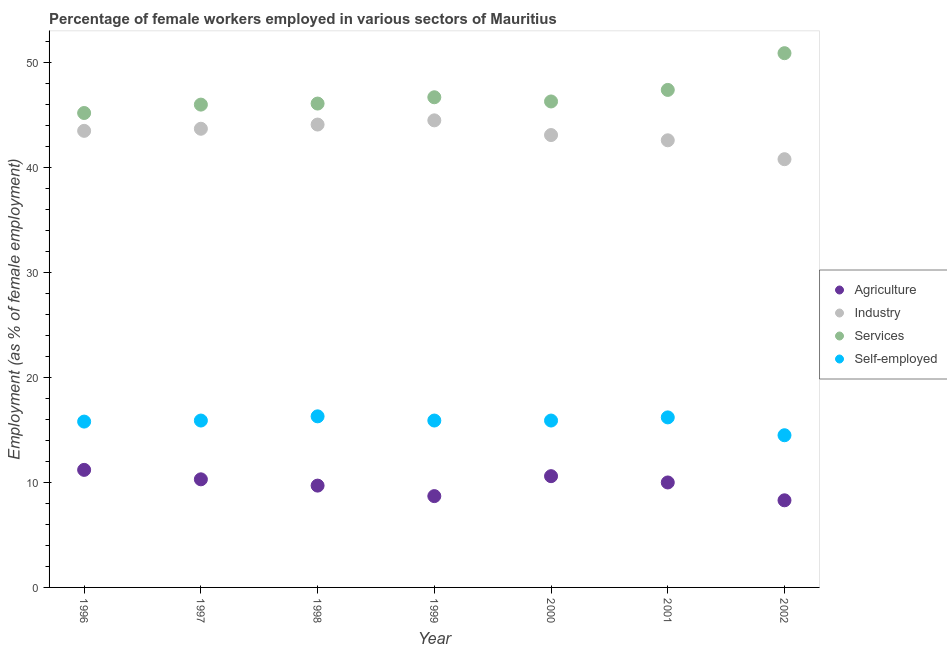How many different coloured dotlines are there?
Ensure brevity in your answer.  4. What is the percentage of female workers in industry in 1996?
Offer a terse response. 43.5. Across all years, what is the maximum percentage of female workers in industry?
Ensure brevity in your answer.  44.5. In which year was the percentage of female workers in agriculture maximum?
Offer a very short reply. 1996. In which year was the percentage of female workers in industry minimum?
Your answer should be compact. 2002. What is the total percentage of self employed female workers in the graph?
Your answer should be very brief. 110.5. What is the difference between the percentage of female workers in industry in 1996 and that in 1997?
Ensure brevity in your answer.  -0.2. What is the difference between the percentage of self employed female workers in 1999 and the percentage of female workers in industry in 2000?
Your answer should be compact. -27.2. What is the average percentage of female workers in industry per year?
Ensure brevity in your answer.  43.19. In the year 1996, what is the difference between the percentage of female workers in services and percentage of female workers in industry?
Offer a very short reply. 1.7. In how many years, is the percentage of female workers in agriculture greater than 22 %?
Make the answer very short. 0. What is the ratio of the percentage of female workers in services in 1999 to that in 2000?
Ensure brevity in your answer.  1.01. Is the percentage of female workers in agriculture in 1997 less than that in 2002?
Give a very brief answer. No. Is the difference between the percentage of female workers in industry in 2000 and 2002 greater than the difference between the percentage of self employed female workers in 2000 and 2002?
Keep it short and to the point. Yes. What is the difference between the highest and the second highest percentage of female workers in agriculture?
Your answer should be very brief. 0.6. What is the difference between the highest and the lowest percentage of self employed female workers?
Your response must be concise. 1.8. In how many years, is the percentage of female workers in agriculture greater than the average percentage of female workers in agriculture taken over all years?
Offer a very short reply. 4. Is the sum of the percentage of female workers in industry in 1996 and 2001 greater than the maximum percentage of female workers in agriculture across all years?
Your answer should be very brief. Yes. Is it the case that in every year, the sum of the percentage of female workers in industry and percentage of female workers in services is greater than the sum of percentage of female workers in agriculture and percentage of self employed female workers?
Offer a terse response. Yes. Is it the case that in every year, the sum of the percentage of female workers in agriculture and percentage of female workers in industry is greater than the percentage of female workers in services?
Keep it short and to the point. No. Does the percentage of female workers in industry monotonically increase over the years?
Offer a very short reply. No. Is the percentage of female workers in services strictly less than the percentage of female workers in industry over the years?
Give a very brief answer. No. How many years are there in the graph?
Keep it short and to the point. 7. What is the difference between two consecutive major ticks on the Y-axis?
Your answer should be compact. 10. Are the values on the major ticks of Y-axis written in scientific E-notation?
Your response must be concise. No. Does the graph contain any zero values?
Make the answer very short. No. Does the graph contain grids?
Offer a terse response. No. How are the legend labels stacked?
Make the answer very short. Vertical. What is the title of the graph?
Ensure brevity in your answer.  Percentage of female workers employed in various sectors of Mauritius. What is the label or title of the Y-axis?
Your answer should be very brief. Employment (as % of female employment). What is the Employment (as % of female employment) in Agriculture in 1996?
Offer a terse response. 11.2. What is the Employment (as % of female employment) of Industry in 1996?
Give a very brief answer. 43.5. What is the Employment (as % of female employment) in Services in 1996?
Make the answer very short. 45.2. What is the Employment (as % of female employment) in Self-employed in 1996?
Offer a very short reply. 15.8. What is the Employment (as % of female employment) of Agriculture in 1997?
Your response must be concise. 10.3. What is the Employment (as % of female employment) in Industry in 1997?
Keep it short and to the point. 43.7. What is the Employment (as % of female employment) of Self-employed in 1997?
Keep it short and to the point. 15.9. What is the Employment (as % of female employment) of Agriculture in 1998?
Offer a terse response. 9.7. What is the Employment (as % of female employment) in Industry in 1998?
Give a very brief answer. 44.1. What is the Employment (as % of female employment) of Services in 1998?
Provide a succinct answer. 46.1. What is the Employment (as % of female employment) in Self-employed in 1998?
Your answer should be compact. 16.3. What is the Employment (as % of female employment) in Agriculture in 1999?
Make the answer very short. 8.7. What is the Employment (as % of female employment) of Industry in 1999?
Offer a terse response. 44.5. What is the Employment (as % of female employment) in Services in 1999?
Keep it short and to the point. 46.7. What is the Employment (as % of female employment) in Self-employed in 1999?
Provide a succinct answer. 15.9. What is the Employment (as % of female employment) in Agriculture in 2000?
Give a very brief answer. 10.6. What is the Employment (as % of female employment) of Industry in 2000?
Provide a short and direct response. 43.1. What is the Employment (as % of female employment) of Services in 2000?
Your answer should be very brief. 46.3. What is the Employment (as % of female employment) of Self-employed in 2000?
Give a very brief answer. 15.9. What is the Employment (as % of female employment) of Agriculture in 2001?
Give a very brief answer. 10. What is the Employment (as % of female employment) of Industry in 2001?
Offer a very short reply. 42.6. What is the Employment (as % of female employment) in Services in 2001?
Provide a succinct answer. 47.4. What is the Employment (as % of female employment) in Self-employed in 2001?
Make the answer very short. 16.2. What is the Employment (as % of female employment) in Agriculture in 2002?
Offer a very short reply. 8.3. What is the Employment (as % of female employment) in Industry in 2002?
Your response must be concise. 40.8. What is the Employment (as % of female employment) of Services in 2002?
Provide a succinct answer. 50.9. Across all years, what is the maximum Employment (as % of female employment) in Agriculture?
Offer a very short reply. 11.2. Across all years, what is the maximum Employment (as % of female employment) in Industry?
Your response must be concise. 44.5. Across all years, what is the maximum Employment (as % of female employment) of Services?
Keep it short and to the point. 50.9. Across all years, what is the maximum Employment (as % of female employment) of Self-employed?
Offer a terse response. 16.3. Across all years, what is the minimum Employment (as % of female employment) of Agriculture?
Keep it short and to the point. 8.3. Across all years, what is the minimum Employment (as % of female employment) of Industry?
Make the answer very short. 40.8. Across all years, what is the minimum Employment (as % of female employment) in Services?
Keep it short and to the point. 45.2. Across all years, what is the minimum Employment (as % of female employment) in Self-employed?
Provide a succinct answer. 14.5. What is the total Employment (as % of female employment) in Agriculture in the graph?
Your response must be concise. 68.8. What is the total Employment (as % of female employment) of Industry in the graph?
Your answer should be very brief. 302.3. What is the total Employment (as % of female employment) in Services in the graph?
Ensure brevity in your answer.  328.6. What is the total Employment (as % of female employment) in Self-employed in the graph?
Provide a short and direct response. 110.5. What is the difference between the Employment (as % of female employment) of Agriculture in 1996 and that in 1997?
Your answer should be compact. 0.9. What is the difference between the Employment (as % of female employment) of Industry in 1996 and that in 1997?
Give a very brief answer. -0.2. What is the difference between the Employment (as % of female employment) of Self-employed in 1996 and that in 1997?
Ensure brevity in your answer.  -0.1. What is the difference between the Employment (as % of female employment) of Self-employed in 1996 and that in 1998?
Ensure brevity in your answer.  -0.5. What is the difference between the Employment (as % of female employment) of Agriculture in 1996 and that in 1999?
Your answer should be compact. 2.5. What is the difference between the Employment (as % of female employment) of Industry in 1996 and that in 1999?
Provide a succinct answer. -1. What is the difference between the Employment (as % of female employment) in Services in 1996 and that in 1999?
Your answer should be very brief. -1.5. What is the difference between the Employment (as % of female employment) in Self-employed in 1996 and that in 1999?
Make the answer very short. -0.1. What is the difference between the Employment (as % of female employment) in Agriculture in 1996 and that in 2000?
Offer a very short reply. 0.6. What is the difference between the Employment (as % of female employment) of Industry in 1996 and that in 2000?
Your answer should be very brief. 0.4. What is the difference between the Employment (as % of female employment) in Services in 1996 and that in 2000?
Your answer should be very brief. -1.1. What is the difference between the Employment (as % of female employment) in Self-employed in 1996 and that in 2000?
Offer a terse response. -0.1. What is the difference between the Employment (as % of female employment) in Industry in 1996 and that in 2001?
Ensure brevity in your answer.  0.9. What is the difference between the Employment (as % of female employment) in Self-employed in 1996 and that in 2001?
Your answer should be compact. -0.4. What is the difference between the Employment (as % of female employment) of Agriculture in 1996 and that in 2002?
Provide a succinct answer. 2.9. What is the difference between the Employment (as % of female employment) in Services in 1996 and that in 2002?
Your answer should be very brief. -5.7. What is the difference between the Employment (as % of female employment) of Self-employed in 1996 and that in 2002?
Offer a very short reply. 1.3. What is the difference between the Employment (as % of female employment) of Agriculture in 1997 and that in 1998?
Offer a very short reply. 0.6. What is the difference between the Employment (as % of female employment) in Self-employed in 1997 and that in 1998?
Your response must be concise. -0.4. What is the difference between the Employment (as % of female employment) of Agriculture in 1997 and that in 1999?
Ensure brevity in your answer.  1.6. What is the difference between the Employment (as % of female employment) in Industry in 1997 and that in 1999?
Offer a terse response. -0.8. What is the difference between the Employment (as % of female employment) in Services in 1997 and that in 1999?
Your response must be concise. -0.7. What is the difference between the Employment (as % of female employment) in Self-employed in 1997 and that in 1999?
Make the answer very short. 0. What is the difference between the Employment (as % of female employment) in Agriculture in 1997 and that in 2000?
Your response must be concise. -0.3. What is the difference between the Employment (as % of female employment) in Industry in 1997 and that in 2000?
Provide a short and direct response. 0.6. What is the difference between the Employment (as % of female employment) in Industry in 1997 and that in 2001?
Your answer should be compact. 1.1. What is the difference between the Employment (as % of female employment) of Industry in 1997 and that in 2002?
Offer a very short reply. 2.9. What is the difference between the Employment (as % of female employment) in Services in 1997 and that in 2002?
Ensure brevity in your answer.  -4.9. What is the difference between the Employment (as % of female employment) in Agriculture in 1998 and that in 1999?
Offer a terse response. 1. What is the difference between the Employment (as % of female employment) of Agriculture in 1998 and that in 2000?
Keep it short and to the point. -0.9. What is the difference between the Employment (as % of female employment) of Industry in 1998 and that in 2000?
Your response must be concise. 1. What is the difference between the Employment (as % of female employment) in Self-employed in 1998 and that in 2000?
Keep it short and to the point. 0.4. What is the difference between the Employment (as % of female employment) of Agriculture in 1998 and that in 2001?
Ensure brevity in your answer.  -0.3. What is the difference between the Employment (as % of female employment) in Industry in 1998 and that in 2001?
Keep it short and to the point. 1.5. What is the difference between the Employment (as % of female employment) in Agriculture in 1998 and that in 2002?
Keep it short and to the point. 1.4. What is the difference between the Employment (as % of female employment) in Industry in 1998 and that in 2002?
Your answer should be very brief. 3.3. What is the difference between the Employment (as % of female employment) of Services in 1998 and that in 2002?
Keep it short and to the point. -4.8. What is the difference between the Employment (as % of female employment) of Self-employed in 1998 and that in 2002?
Offer a terse response. 1.8. What is the difference between the Employment (as % of female employment) in Agriculture in 1999 and that in 2000?
Make the answer very short. -1.9. What is the difference between the Employment (as % of female employment) of Industry in 1999 and that in 2000?
Your answer should be compact. 1.4. What is the difference between the Employment (as % of female employment) in Self-employed in 1999 and that in 2000?
Make the answer very short. 0. What is the difference between the Employment (as % of female employment) of Industry in 1999 and that in 2001?
Make the answer very short. 1.9. What is the difference between the Employment (as % of female employment) in Agriculture in 1999 and that in 2002?
Ensure brevity in your answer.  0.4. What is the difference between the Employment (as % of female employment) of Industry in 1999 and that in 2002?
Provide a short and direct response. 3.7. What is the difference between the Employment (as % of female employment) in Self-employed in 1999 and that in 2002?
Make the answer very short. 1.4. What is the difference between the Employment (as % of female employment) of Agriculture in 2000 and that in 2001?
Your answer should be compact. 0.6. What is the difference between the Employment (as % of female employment) in Services in 2000 and that in 2001?
Ensure brevity in your answer.  -1.1. What is the difference between the Employment (as % of female employment) in Self-employed in 2000 and that in 2001?
Keep it short and to the point. -0.3. What is the difference between the Employment (as % of female employment) of Agriculture in 2000 and that in 2002?
Your response must be concise. 2.3. What is the difference between the Employment (as % of female employment) of Industry in 2000 and that in 2002?
Keep it short and to the point. 2.3. What is the difference between the Employment (as % of female employment) of Self-employed in 2000 and that in 2002?
Keep it short and to the point. 1.4. What is the difference between the Employment (as % of female employment) of Agriculture in 2001 and that in 2002?
Ensure brevity in your answer.  1.7. What is the difference between the Employment (as % of female employment) in Services in 2001 and that in 2002?
Give a very brief answer. -3.5. What is the difference between the Employment (as % of female employment) of Self-employed in 2001 and that in 2002?
Provide a succinct answer. 1.7. What is the difference between the Employment (as % of female employment) in Agriculture in 1996 and the Employment (as % of female employment) in Industry in 1997?
Give a very brief answer. -32.5. What is the difference between the Employment (as % of female employment) in Agriculture in 1996 and the Employment (as % of female employment) in Services in 1997?
Provide a short and direct response. -34.8. What is the difference between the Employment (as % of female employment) in Industry in 1996 and the Employment (as % of female employment) in Self-employed in 1997?
Ensure brevity in your answer.  27.6. What is the difference between the Employment (as % of female employment) of Services in 1996 and the Employment (as % of female employment) of Self-employed in 1997?
Provide a succinct answer. 29.3. What is the difference between the Employment (as % of female employment) in Agriculture in 1996 and the Employment (as % of female employment) in Industry in 1998?
Your response must be concise. -32.9. What is the difference between the Employment (as % of female employment) in Agriculture in 1996 and the Employment (as % of female employment) in Services in 1998?
Your answer should be compact. -34.9. What is the difference between the Employment (as % of female employment) of Agriculture in 1996 and the Employment (as % of female employment) of Self-employed in 1998?
Offer a terse response. -5.1. What is the difference between the Employment (as % of female employment) of Industry in 1996 and the Employment (as % of female employment) of Services in 1998?
Keep it short and to the point. -2.6. What is the difference between the Employment (as % of female employment) in Industry in 1996 and the Employment (as % of female employment) in Self-employed in 1998?
Make the answer very short. 27.2. What is the difference between the Employment (as % of female employment) in Services in 1996 and the Employment (as % of female employment) in Self-employed in 1998?
Offer a very short reply. 28.9. What is the difference between the Employment (as % of female employment) of Agriculture in 1996 and the Employment (as % of female employment) of Industry in 1999?
Provide a succinct answer. -33.3. What is the difference between the Employment (as % of female employment) in Agriculture in 1996 and the Employment (as % of female employment) in Services in 1999?
Ensure brevity in your answer.  -35.5. What is the difference between the Employment (as % of female employment) of Industry in 1996 and the Employment (as % of female employment) of Services in 1999?
Keep it short and to the point. -3.2. What is the difference between the Employment (as % of female employment) of Industry in 1996 and the Employment (as % of female employment) of Self-employed in 1999?
Ensure brevity in your answer.  27.6. What is the difference between the Employment (as % of female employment) of Services in 1996 and the Employment (as % of female employment) of Self-employed in 1999?
Ensure brevity in your answer.  29.3. What is the difference between the Employment (as % of female employment) of Agriculture in 1996 and the Employment (as % of female employment) of Industry in 2000?
Provide a short and direct response. -31.9. What is the difference between the Employment (as % of female employment) in Agriculture in 1996 and the Employment (as % of female employment) in Services in 2000?
Keep it short and to the point. -35.1. What is the difference between the Employment (as % of female employment) of Industry in 1996 and the Employment (as % of female employment) of Services in 2000?
Provide a short and direct response. -2.8. What is the difference between the Employment (as % of female employment) in Industry in 1996 and the Employment (as % of female employment) in Self-employed in 2000?
Make the answer very short. 27.6. What is the difference between the Employment (as % of female employment) in Services in 1996 and the Employment (as % of female employment) in Self-employed in 2000?
Your answer should be compact. 29.3. What is the difference between the Employment (as % of female employment) in Agriculture in 1996 and the Employment (as % of female employment) in Industry in 2001?
Keep it short and to the point. -31.4. What is the difference between the Employment (as % of female employment) of Agriculture in 1996 and the Employment (as % of female employment) of Services in 2001?
Keep it short and to the point. -36.2. What is the difference between the Employment (as % of female employment) in Agriculture in 1996 and the Employment (as % of female employment) in Self-employed in 2001?
Keep it short and to the point. -5. What is the difference between the Employment (as % of female employment) in Industry in 1996 and the Employment (as % of female employment) in Self-employed in 2001?
Offer a terse response. 27.3. What is the difference between the Employment (as % of female employment) of Agriculture in 1996 and the Employment (as % of female employment) of Industry in 2002?
Your response must be concise. -29.6. What is the difference between the Employment (as % of female employment) in Agriculture in 1996 and the Employment (as % of female employment) in Services in 2002?
Offer a terse response. -39.7. What is the difference between the Employment (as % of female employment) of Agriculture in 1996 and the Employment (as % of female employment) of Self-employed in 2002?
Offer a very short reply. -3.3. What is the difference between the Employment (as % of female employment) of Industry in 1996 and the Employment (as % of female employment) of Services in 2002?
Your answer should be compact. -7.4. What is the difference between the Employment (as % of female employment) of Industry in 1996 and the Employment (as % of female employment) of Self-employed in 2002?
Keep it short and to the point. 29. What is the difference between the Employment (as % of female employment) in Services in 1996 and the Employment (as % of female employment) in Self-employed in 2002?
Your answer should be compact. 30.7. What is the difference between the Employment (as % of female employment) in Agriculture in 1997 and the Employment (as % of female employment) in Industry in 1998?
Give a very brief answer. -33.8. What is the difference between the Employment (as % of female employment) in Agriculture in 1997 and the Employment (as % of female employment) in Services in 1998?
Offer a very short reply. -35.8. What is the difference between the Employment (as % of female employment) in Industry in 1997 and the Employment (as % of female employment) in Services in 1998?
Offer a terse response. -2.4. What is the difference between the Employment (as % of female employment) in Industry in 1997 and the Employment (as % of female employment) in Self-employed in 1998?
Your response must be concise. 27.4. What is the difference between the Employment (as % of female employment) in Services in 1997 and the Employment (as % of female employment) in Self-employed in 1998?
Give a very brief answer. 29.7. What is the difference between the Employment (as % of female employment) of Agriculture in 1997 and the Employment (as % of female employment) of Industry in 1999?
Your answer should be compact. -34.2. What is the difference between the Employment (as % of female employment) in Agriculture in 1997 and the Employment (as % of female employment) in Services in 1999?
Give a very brief answer. -36.4. What is the difference between the Employment (as % of female employment) of Agriculture in 1997 and the Employment (as % of female employment) of Self-employed in 1999?
Keep it short and to the point. -5.6. What is the difference between the Employment (as % of female employment) in Industry in 1997 and the Employment (as % of female employment) in Services in 1999?
Keep it short and to the point. -3. What is the difference between the Employment (as % of female employment) in Industry in 1997 and the Employment (as % of female employment) in Self-employed in 1999?
Your answer should be very brief. 27.8. What is the difference between the Employment (as % of female employment) of Services in 1997 and the Employment (as % of female employment) of Self-employed in 1999?
Offer a very short reply. 30.1. What is the difference between the Employment (as % of female employment) of Agriculture in 1997 and the Employment (as % of female employment) of Industry in 2000?
Offer a terse response. -32.8. What is the difference between the Employment (as % of female employment) in Agriculture in 1997 and the Employment (as % of female employment) in Services in 2000?
Provide a short and direct response. -36. What is the difference between the Employment (as % of female employment) of Industry in 1997 and the Employment (as % of female employment) of Services in 2000?
Provide a short and direct response. -2.6. What is the difference between the Employment (as % of female employment) of Industry in 1997 and the Employment (as % of female employment) of Self-employed in 2000?
Make the answer very short. 27.8. What is the difference between the Employment (as % of female employment) of Services in 1997 and the Employment (as % of female employment) of Self-employed in 2000?
Your answer should be very brief. 30.1. What is the difference between the Employment (as % of female employment) in Agriculture in 1997 and the Employment (as % of female employment) in Industry in 2001?
Your answer should be compact. -32.3. What is the difference between the Employment (as % of female employment) of Agriculture in 1997 and the Employment (as % of female employment) of Services in 2001?
Give a very brief answer. -37.1. What is the difference between the Employment (as % of female employment) of Industry in 1997 and the Employment (as % of female employment) of Self-employed in 2001?
Keep it short and to the point. 27.5. What is the difference between the Employment (as % of female employment) in Services in 1997 and the Employment (as % of female employment) in Self-employed in 2001?
Ensure brevity in your answer.  29.8. What is the difference between the Employment (as % of female employment) of Agriculture in 1997 and the Employment (as % of female employment) of Industry in 2002?
Offer a very short reply. -30.5. What is the difference between the Employment (as % of female employment) in Agriculture in 1997 and the Employment (as % of female employment) in Services in 2002?
Provide a succinct answer. -40.6. What is the difference between the Employment (as % of female employment) in Agriculture in 1997 and the Employment (as % of female employment) in Self-employed in 2002?
Offer a terse response. -4.2. What is the difference between the Employment (as % of female employment) in Industry in 1997 and the Employment (as % of female employment) in Self-employed in 2002?
Make the answer very short. 29.2. What is the difference between the Employment (as % of female employment) in Services in 1997 and the Employment (as % of female employment) in Self-employed in 2002?
Ensure brevity in your answer.  31.5. What is the difference between the Employment (as % of female employment) of Agriculture in 1998 and the Employment (as % of female employment) of Industry in 1999?
Your response must be concise. -34.8. What is the difference between the Employment (as % of female employment) in Agriculture in 1998 and the Employment (as % of female employment) in Services in 1999?
Offer a very short reply. -37. What is the difference between the Employment (as % of female employment) of Industry in 1998 and the Employment (as % of female employment) of Services in 1999?
Offer a terse response. -2.6. What is the difference between the Employment (as % of female employment) in Industry in 1998 and the Employment (as % of female employment) in Self-employed in 1999?
Make the answer very short. 28.2. What is the difference between the Employment (as % of female employment) in Services in 1998 and the Employment (as % of female employment) in Self-employed in 1999?
Your answer should be compact. 30.2. What is the difference between the Employment (as % of female employment) in Agriculture in 1998 and the Employment (as % of female employment) in Industry in 2000?
Ensure brevity in your answer.  -33.4. What is the difference between the Employment (as % of female employment) of Agriculture in 1998 and the Employment (as % of female employment) of Services in 2000?
Provide a succinct answer. -36.6. What is the difference between the Employment (as % of female employment) in Industry in 1998 and the Employment (as % of female employment) in Services in 2000?
Make the answer very short. -2.2. What is the difference between the Employment (as % of female employment) in Industry in 1998 and the Employment (as % of female employment) in Self-employed in 2000?
Your answer should be compact. 28.2. What is the difference between the Employment (as % of female employment) of Services in 1998 and the Employment (as % of female employment) of Self-employed in 2000?
Your answer should be compact. 30.2. What is the difference between the Employment (as % of female employment) of Agriculture in 1998 and the Employment (as % of female employment) of Industry in 2001?
Offer a very short reply. -32.9. What is the difference between the Employment (as % of female employment) in Agriculture in 1998 and the Employment (as % of female employment) in Services in 2001?
Give a very brief answer. -37.7. What is the difference between the Employment (as % of female employment) in Industry in 1998 and the Employment (as % of female employment) in Self-employed in 2001?
Your answer should be compact. 27.9. What is the difference between the Employment (as % of female employment) in Services in 1998 and the Employment (as % of female employment) in Self-employed in 2001?
Give a very brief answer. 29.9. What is the difference between the Employment (as % of female employment) of Agriculture in 1998 and the Employment (as % of female employment) of Industry in 2002?
Provide a short and direct response. -31.1. What is the difference between the Employment (as % of female employment) in Agriculture in 1998 and the Employment (as % of female employment) in Services in 2002?
Give a very brief answer. -41.2. What is the difference between the Employment (as % of female employment) of Agriculture in 1998 and the Employment (as % of female employment) of Self-employed in 2002?
Provide a succinct answer. -4.8. What is the difference between the Employment (as % of female employment) of Industry in 1998 and the Employment (as % of female employment) of Self-employed in 2002?
Offer a terse response. 29.6. What is the difference between the Employment (as % of female employment) of Services in 1998 and the Employment (as % of female employment) of Self-employed in 2002?
Offer a very short reply. 31.6. What is the difference between the Employment (as % of female employment) of Agriculture in 1999 and the Employment (as % of female employment) of Industry in 2000?
Keep it short and to the point. -34.4. What is the difference between the Employment (as % of female employment) in Agriculture in 1999 and the Employment (as % of female employment) in Services in 2000?
Provide a succinct answer. -37.6. What is the difference between the Employment (as % of female employment) of Agriculture in 1999 and the Employment (as % of female employment) of Self-employed in 2000?
Ensure brevity in your answer.  -7.2. What is the difference between the Employment (as % of female employment) of Industry in 1999 and the Employment (as % of female employment) of Services in 2000?
Offer a terse response. -1.8. What is the difference between the Employment (as % of female employment) in Industry in 1999 and the Employment (as % of female employment) in Self-employed in 2000?
Your answer should be compact. 28.6. What is the difference between the Employment (as % of female employment) in Services in 1999 and the Employment (as % of female employment) in Self-employed in 2000?
Make the answer very short. 30.8. What is the difference between the Employment (as % of female employment) in Agriculture in 1999 and the Employment (as % of female employment) in Industry in 2001?
Provide a succinct answer. -33.9. What is the difference between the Employment (as % of female employment) in Agriculture in 1999 and the Employment (as % of female employment) in Services in 2001?
Offer a terse response. -38.7. What is the difference between the Employment (as % of female employment) of Industry in 1999 and the Employment (as % of female employment) of Self-employed in 2001?
Keep it short and to the point. 28.3. What is the difference between the Employment (as % of female employment) of Services in 1999 and the Employment (as % of female employment) of Self-employed in 2001?
Your answer should be very brief. 30.5. What is the difference between the Employment (as % of female employment) of Agriculture in 1999 and the Employment (as % of female employment) of Industry in 2002?
Your response must be concise. -32.1. What is the difference between the Employment (as % of female employment) in Agriculture in 1999 and the Employment (as % of female employment) in Services in 2002?
Offer a terse response. -42.2. What is the difference between the Employment (as % of female employment) in Industry in 1999 and the Employment (as % of female employment) in Services in 2002?
Offer a very short reply. -6.4. What is the difference between the Employment (as % of female employment) in Services in 1999 and the Employment (as % of female employment) in Self-employed in 2002?
Your answer should be compact. 32.2. What is the difference between the Employment (as % of female employment) in Agriculture in 2000 and the Employment (as % of female employment) in Industry in 2001?
Give a very brief answer. -32. What is the difference between the Employment (as % of female employment) of Agriculture in 2000 and the Employment (as % of female employment) of Services in 2001?
Offer a terse response. -36.8. What is the difference between the Employment (as % of female employment) of Industry in 2000 and the Employment (as % of female employment) of Self-employed in 2001?
Your answer should be very brief. 26.9. What is the difference between the Employment (as % of female employment) of Services in 2000 and the Employment (as % of female employment) of Self-employed in 2001?
Provide a short and direct response. 30.1. What is the difference between the Employment (as % of female employment) of Agriculture in 2000 and the Employment (as % of female employment) of Industry in 2002?
Provide a succinct answer. -30.2. What is the difference between the Employment (as % of female employment) of Agriculture in 2000 and the Employment (as % of female employment) of Services in 2002?
Provide a short and direct response. -40.3. What is the difference between the Employment (as % of female employment) in Agriculture in 2000 and the Employment (as % of female employment) in Self-employed in 2002?
Provide a short and direct response. -3.9. What is the difference between the Employment (as % of female employment) of Industry in 2000 and the Employment (as % of female employment) of Services in 2002?
Provide a succinct answer. -7.8. What is the difference between the Employment (as % of female employment) in Industry in 2000 and the Employment (as % of female employment) in Self-employed in 2002?
Your response must be concise. 28.6. What is the difference between the Employment (as % of female employment) in Services in 2000 and the Employment (as % of female employment) in Self-employed in 2002?
Your answer should be compact. 31.8. What is the difference between the Employment (as % of female employment) in Agriculture in 2001 and the Employment (as % of female employment) in Industry in 2002?
Your response must be concise. -30.8. What is the difference between the Employment (as % of female employment) in Agriculture in 2001 and the Employment (as % of female employment) in Services in 2002?
Offer a very short reply. -40.9. What is the difference between the Employment (as % of female employment) in Agriculture in 2001 and the Employment (as % of female employment) in Self-employed in 2002?
Provide a succinct answer. -4.5. What is the difference between the Employment (as % of female employment) in Industry in 2001 and the Employment (as % of female employment) in Services in 2002?
Make the answer very short. -8.3. What is the difference between the Employment (as % of female employment) of Industry in 2001 and the Employment (as % of female employment) of Self-employed in 2002?
Your response must be concise. 28.1. What is the difference between the Employment (as % of female employment) in Services in 2001 and the Employment (as % of female employment) in Self-employed in 2002?
Your answer should be very brief. 32.9. What is the average Employment (as % of female employment) in Agriculture per year?
Provide a succinct answer. 9.83. What is the average Employment (as % of female employment) in Industry per year?
Your answer should be compact. 43.19. What is the average Employment (as % of female employment) in Services per year?
Provide a succinct answer. 46.94. What is the average Employment (as % of female employment) in Self-employed per year?
Provide a succinct answer. 15.79. In the year 1996, what is the difference between the Employment (as % of female employment) of Agriculture and Employment (as % of female employment) of Industry?
Provide a succinct answer. -32.3. In the year 1996, what is the difference between the Employment (as % of female employment) of Agriculture and Employment (as % of female employment) of Services?
Your response must be concise. -34. In the year 1996, what is the difference between the Employment (as % of female employment) in Agriculture and Employment (as % of female employment) in Self-employed?
Offer a very short reply. -4.6. In the year 1996, what is the difference between the Employment (as % of female employment) in Industry and Employment (as % of female employment) in Services?
Make the answer very short. -1.7. In the year 1996, what is the difference between the Employment (as % of female employment) of Industry and Employment (as % of female employment) of Self-employed?
Make the answer very short. 27.7. In the year 1996, what is the difference between the Employment (as % of female employment) in Services and Employment (as % of female employment) in Self-employed?
Provide a short and direct response. 29.4. In the year 1997, what is the difference between the Employment (as % of female employment) of Agriculture and Employment (as % of female employment) of Industry?
Offer a terse response. -33.4. In the year 1997, what is the difference between the Employment (as % of female employment) in Agriculture and Employment (as % of female employment) in Services?
Keep it short and to the point. -35.7. In the year 1997, what is the difference between the Employment (as % of female employment) of Agriculture and Employment (as % of female employment) of Self-employed?
Provide a succinct answer. -5.6. In the year 1997, what is the difference between the Employment (as % of female employment) of Industry and Employment (as % of female employment) of Services?
Provide a short and direct response. -2.3. In the year 1997, what is the difference between the Employment (as % of female employment) of Industry and Employment (as % of female employment) of Self-employed?
Make the answer very short. 27.8. In the year 1997, what is the difference between the Employment (as % of female employment) of Services and Employment (as % of female employment) of Self-employed?
Offer a very short reply. 30.1. In the year 1998, what is the difference between the Employment (as % of female employment) of Agriculture and Employment (as % of female employment) of Industry?
Offer a terse response. -34.4. In the year 1998, what is the difference between the Employment (as % of female employment) of Agriculture and Employment (as % of female employment) of Services?
Ensure brevity in your answer.  -36.4. In the year 1998, what is the difference between the Employment (as % of female employment) of Agriculture and Employment (as % of female employment) of Self-employed?
Your response must be concise. -6.6. In the year 1998, what is the difference between the Employment (as % of female employment) of Industry and Employment (as % of female employment) of Self-employed?
Your answer should be very brief. 27.8. In the year 1998, what is the difference between the Employment (as % of female employment) of Services and Employment (as % of female employment) of Self-employed?
Provide a succinct answer. 29.8. In the year 1999, what is the difference between the Employment (as % of female employment) in Agriculture and Employment (as % of female employment) in Industry?
Make the answer very short. -35.8. In the year 1999, what is the difference between the Employment (as % of female employment) in Agriculture and Employment (as % of female employment) in Services?
Your answer should be very brief. -38. In the year 1999, what is the difference between the Employment (as % of female employment) in Industry and Employment (as % of female employment) in Services?
Your response must be concise. -2.2. In the year 1999, what is the difference between the Employment (as % of female employment) in Industry and Employment (as % of female employment) in Self-employed?
Provide a succinct answer. 28.6. In the year 1999, what is the difference between the Employment (as % of female employment) of Services and Employment (as % of female employment) of Self-employed?
Ensure brevity in your answer.  30.8. In the year 2000, what is the difference between the Employment (as % of female employment) of Agriculture and Employment (as % of female employment) of Industry?
Provide a succinct answer. -32.5. In the year 2000, what is the difference between the Employment (as % of female employment) of Agriculture and Employment (as % of female employment) of Services?
Your answer should be compact. -35.7. In the year 2000, what is the difference between the Employment (as % of female employment) in Industry and Employment (as % of female employment) in Self-employed?
Give a very brief answer. 27.2. In the year 2000, what is the difference between the Employment (as % of female employment) in Services and Employment (as % of female employment) in Self-employed?
Offer a terse response. 30.4. In the year 2001, what is the difference between the Employment (as % of female employment) in Agriculture and Employment (as % of female employment) in Industry?
Offer a very short reply. -32.6. In the year 2001, what is the difference between the Employment (as % of female employment) of Agriculture and Employment (as % of female employment) of Services?
Your answer should be very brief. -37.4. In the year 2001, what is the difference between the Employment (as % of female employment) in Agriculture and Employment (as % of female employment) in Self-employed?
Your answer should be compact. -6.2. In the year 2001, what is the difference between the Employment (as % of female employment) of Industry and Employment (as % of female employment) of Self-employed?
Provide a short and direct response. 26.4. In the year 2001, what is the difference between the Employment (as % of female employment) of Services and Employment (as % of female employment) of Self-employed?
Give a very brief answer. 31.2. In the year 2002, what is the difference between the Employment (as % of female employment) in Agriculture and Employment (as % of female employment) in Industry?
Ensure brevity in your answer.  -32.5. In the year 2002, what is the difference between the Employment (as % of female employment) in Agriculture and Employment (as % of female employment) in Services?
Keep it short and to the point. -42.6. In the year 2002, what is the difference between the Employment (as % of female employment) of Agriculture and Employment (as % of female employment) of Self-employed?
Offer a very short reply. -6.2. In the year 2002, what is the difference between the Employment (as % of female employment) in Industry and Employment (as % of female employment) in Services?
Keep it short and to the point. -10.1. In the year 2002, what is the difference between the Employment (as % of female employment) of Industry and Employment (as % of female employment) of Self-employed?
Provide a succinct answer. 26.3. In the year 2002, what is the difference between the Employment (as % of female employment) in Services and Employment (as % of female employment) in Self-employed?
Your response must be concise. 36.4. What is the ratio of the Employment (as % of female employment) in Agriculture in 1996 to that in 1997?
Keep it short and to the point. 1.09. What is the ratio of the Employment (as % of female employment) of Services in 1996 to that in 1997?
Provide a short and direct response. 0.98. What is the ratio of the Employment (as % of female employment) of Self-employed in 1996 to that in 1997?
Offer a very short reply. 0.99. What is the ratio of the Employment (as % of female employment) in Agriculture in 1996 to that in 1998?
Ensure brevity in your answer.  1.15. What is the ratio of the Employment (as % of female employment) of Industry in 1996 to that in 1998?
Give a very brief answer. 0.99. What is the ratio of the Employment (as % of female employment) in Services in 1996 to that in 1998?
Offer a terse response. 0.98. What is the ratio of the Employment (as % of female employment) in Self-employed in 1996 to that in 1998?
Your response must be concise. 0.97. What is the ratio of the Employment (as % of female employment) in Agriculture in 1996 to that in 1999?
Your response must be concise. 1.29. What is the ratio of the Employment (as % of female employment) in Industry in 1996 to that in 1999?
Keep it short and to the point. 0.98. What is the ratio of the Employment (as % of female employment) of Services in 1996 to that in 1999?
Ensure brevity in your answer.  0.97. What is the ratio of the Employment (as % of female employment) of Self-employed in 1996 to that in 1999?
Make the answer very short. 0.99. What is the ratio of the Employment (as % of female employment) of Agriculture in 1996 to that in 2000?
Your response must be concise. 1.06. What is the ratio of the Employment (as % of female employment) in Industry in 1996 to that in 2000?
Give a very brief answer. 1.01. What is the ratio of the Employment (as % of female employment) of Services in 1996 to that in 2000?
Your answer should be very brief. 0.98. What is the ratio of the Employment (as % of female employment) of Self-employed in 1996 to that in 2000?
Provide a short and direct response. 0.99. What is the ratio of the Employment (as % of female employment) in Agriculture in 1996 to that in 2001?
Keep it short and to the point. 1.12. What is the ratio of the Employment (as % of female employment) of Industry in 1996 to that in 2001?
Your answer should be very brief. 1.02. What is the ratio of the Employment (as % of female employment) in Services in 1996 to that in 2001?
Your answer should be very brief. 0.95. What is the ratio of the Employment (as % of female employment) of Self-employed in 1996 to that in 2001?
Make the answer very short. 0.98. What is the ratio of the Employment (as % of female employment) of Agriculture in 1996 to that in 2002?
Ensure brevity in your answer.  1.35. What is the ratio of the Employment (as % of female employment) in Industry in 1996 to that in 2002?
Make the answer very short. 1.07. What is the ratio of the Employment (as % of female employment) in Services in 1996 to that in 2002?
Offer a very short reply. 0.89. What is the ratio of the Employment (as % of female employment) in Self-employed in 1996 to that in 2002?
Give a very brief answer. 1.09. What is the ratio of the Employment (as % of female employment) of Agriculture in 1997 to that in 1998?
Provide a succinct answer. 1.06. What is the ratio of the Employment (as % of female employment) in Industry in 1997 to that in 1998?
Offer a very short reply. 0.99. What is the ratio of the Employment (as % of female employment) of Self-employed in 1997 to that in 1998?
Provide a short and direct response. 0.98. What is the ratio of the Employment (as % of female employment) in Agriculture in 1997 to that in 1999?
Give a very brief answer. 1.18. What is the ratio of the Employment (as % of female employment) of Industry in 1997 to that in 1999?
Give a very brief answer. 0.98. What is the ratio of the Employment (as % of female employment) in Self-employed in 1997 to that in 1999?
Offer a very short reply. 1. What is the ratio of the Employment (as % of female employment) of Agriculture in 1997 to that in 2000?
Offer a very short reply. 0.97. What is the ratio of the Employment (as % of female employment) of Industry in 1997 to that in 2000?
Provide a short and direct response. 1.01. What is the ratio of the Employment (as % of female employment) of Services in 1997 to that in 2000?
Ensure brevity in your answer.  0.99. What is the ratio of the Employment (as % of female employment) of Industry in 1997 to that in 2001?
Make the answer very short. 1.03. What is the ratio of the Employment (as % of female employment) of Services in 1997 to that in 2001?
Keep it short and to the point. 0.97. What is the ratio of the Employment (as % of female employment) of Self-employed in 1997 to that in 2001?
Your answer should be compact. 0.98. What is the ratio of the Employment (as % of female employment) of Agriculture in 1997 to that in 2002?
Your answer should be compact. 1.24. What is the ratio of the Employment (as % of female employment) of Industry in 1997 to that in 2002?
Your answer should be very brief. 1.07. What is the ratio of the Employment (as % of female employment) in Services in 1997 to that in 2002?
Your response must be concise. 0.9. What is the ratio of the Employment (as % of female employment) of Self-employed in 1997 to that in 2002?
Provide a short and direct response. 1.1. What is the ratio of the Employment (as % of female employment) of Agriculture in 1998 to that in 1999?
Offer a terse response. 1.11. What is the ratio of the Employment (as % of female employment) of Industry in 1998 to that in 1999?
Make the answer very short. 0.99. What is the ratio of the Employment (as % of female employment) in Services in 1998 to that in 1999?
Offer a very short reply. 0.99. What is the ratio of the Employment (as % of female employment) in Self-employed in 1998 to that in 1999?
Ensure brevity in your answer.  1.03. What is the ratio of the Employment (as % of female employment) in Agriculture in 1998 to that in 2000?
Your answer should be compact. 0.92. What is the ratio of the Employment (as % of female employment) of Industry in 1998 to that in 2000?
Provide a succinct answer. 1.02. What is the ratio of the Employment (as % of female employment) of Services in 1998 to that in 2000?
Offer a terse response. 1. What is the ratio of the Employment (as % of female employment) of Self-employed in 1998 to that in 2000?
Make the answer very short. 1.03. What is the ratio of the Employment (as % of female employment) of Agriculture in 1998 to that in 2001?
Offer a terse response. 0.97. What is the ratio of the Employment (as % of female employment) of Industry in 1998 to that in 2001?
Your response must be concise. 1.04. What is the ratio of the Employment (as % of female employment) of Services in 1998 to that in 2001?
Your response must be concise. 0.97. What is the ratio of the Employment (as % of female employment) in Agriculture in 1998 to that in 2002?
Ensure brevity in your answer.  1.17. What is the ratio of the Employment (as % of female employment) in Industry in 1998 to that in 2002?
Offer a terse response. 1.08. What is the ratio of the Employment (as % of female employment) in Services in 1998 to that in 2002?
Provide a short and direct response. 0.91. What is the ratio of the Employment (as % of female employment) in Self-employed in 1998 to that in 2002?
Offer a very short reply. 1.12. What is the ratio of the Employment (as % of female employment) in Agriculture in 1999 to that in 2000?
Offer a very short reply. 0.82. What is the ratio of the Employment (as % of female employment) of Industry in 1999 to that in 2000?
Offer a very short reply. 1.03. What is the ratio of the Employment (as % of female employment) of Services in 1999 to that in 2000?
Your answer should be very brief. 1.01. What is the ratio of the Employment (as % of female employment) of Self-employed in 1999 to that in 2000?
Offer a very short reply. 1. What is the ratio of the Employment (as % of female employment) in Agriculture in 1999 to that in 2001?
Make the answer very short. 0.87. What is the ratio of the Employment (as % of female employment) in Industry in 1999 to that in 2001?
Make the answer very short. 1.04. What is the ratio of the Employment (as % of female employment) of Services in 1999 to that in 2001?
Your answer should be very brief. 0.99. What is the ratio of the Employment (as % of female employment) in Self-employed in 1999 to that in 2001?
Ensure brevity in your answer.  0.98. What is the ratio of the Employment (as % of female employment) of Agriculture in 1999 to that in 2002?
Ensure brevity in your answer.  1.05. What is the ratio of the Employment (as % of female employment) in Industry in 1999 to that in 2002?
Give a very brief answer. 1.09. What is the ratio of the Employment (as % of female employment) in Services in 1999 to that in 2002?
Your response must be concise. 0.92. What is the ratio of the Employment (as % of female employment) in Self-employed in 1999 to that in 2002?
Provide a succinct answer. 1.1. What is the ratio of the Employment (as % of female employment) in Agriculture in 2000 to that in 2001?
Provide a succinct answer. 1.06. What is the ratio of the Employment (as % of female employment) of Industry in 2000 to that in 2001?
Offer a terse response. 1.01. What is the ratio of the Employment (as % of female employment) in Services in 2000 to that in 2001?
Your response must be concise. 0.98. What is the ratio of the Employment (as % of female employment) in Self-employed in 2000 to that in 2001?
Offer a terse response. 0.98. What is the ratio of the Employment (as % of female employment) in Agriculture in 2000 to that in 2002?
Ensure brevity in your answer.  1.28. What is the ratio of the Employment (as % of female employment) in Industry in 2000 to that in 2002?
Ensure brevity in your answer.  1.06. What is the ratio of the Employment (as % of female employment) in Services in 2000 to that in 2002?
Your answer should be compact. 0.91. What is the ratio of the Employment (as % of female employment) of Self-employed in 2000 to that in 2002?
Provide a succinct answer. 1.1. What is the ratio of the Employment (as % of female employment) in Agriculture in 2001 to that in 2002?
Offer a terse response. 1.2. What is the ratio of the Employment (as % of female employment) in Industry in 2001 to that in 2002?
Make the answer very short. 1.04. What is the ratio of the Employment (as % of female employment) of Services in 2001 to that in 2002?
Offer a terse response. 0.93. What is the ratio of the Employment (as % of female employment) in Self-employed in 2001 to that in 2002?
Your response must be concise. 1.12. What is the difference between the highest and the second highest Employment (as % of female employment) in Industry?
Your response must be concise. 0.4. What is the difference between the highest and the second highest Employment (as % of female employment) of Self-employed?
Offer a terse response. 0.1. What is the difference between the highest and the lowest Employment (as % of female employment) of Agriculture?
Ensure brevity in your answer.  2.9. What is the difference between the highest and the lowest Employment (as % of female employment) of Services?
Keep it short and to the point. 5.7. What is the difference between the highest and the lowest Employment (as % of female employment) in Self-employed?
Keep it short and to the point. 1.8. 